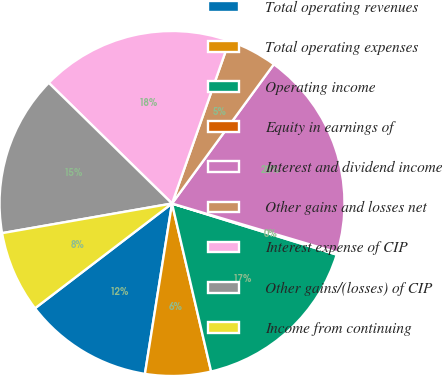Convert chart to OTSL. <chart><loc_0><loc_0><loc_500><loc_500><pie_chart><fcel>Total operating revenues<fcel>Total operating expenses<fcel>Operating income<fcel>Equity in earnings of<fcel>Interest and dividend income<fcel>Other gains and losses net<fcel>Interest expense of CIP<fcel>Other gains/(losses) of CIP<fcel>Income from continuing<nl><fcel>12.1%<fcel>6.15%<fcel>16.57%<fcel>0.2%<fcel>19.54%<fcel>4.66%<fcel>18.06%<fcel>15.08%<fcel>7.64%<nl></chart> 